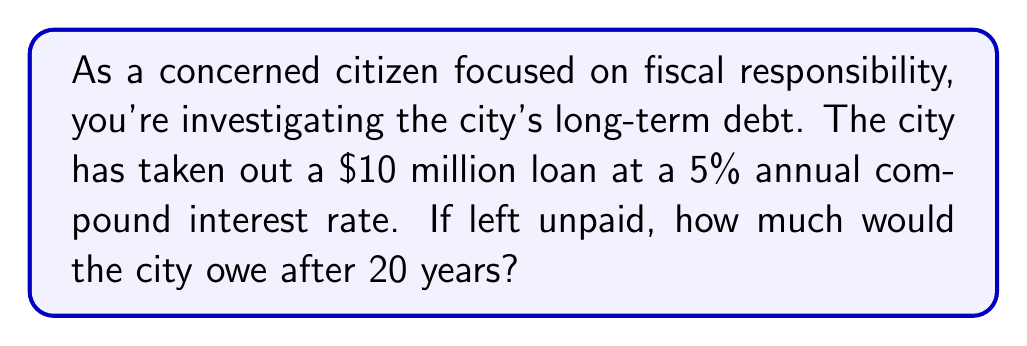Can you answer this question? To solve this problem, we'll use the compound interest formula:

$$ A = P(1 + r)^t $$

Where:
$A$ = Final amount
$P$ = Principal (initial amount)
$r$ = Annual interest rate (as a decimal)
$t$ = Time in years

Given:
$P = \$10,000,000$
$r = 0.05$ (5% converted to decimal)
$t = 20$ years

Let's substitute these values into the formula:

$$ A = 10,000,000(1 + 0.05)^{20} $$

Now, let's calculate step-by-step:

1) First, calculate $(1 + 0.05)^{20}$:
   $$(1.05)^{20} \approx 2.6532977$$

2) Multiply this by the principal:
   $$10,000,000 \times 2.6532977 = 26,532,977$$

Therefore, after 20 years, the city would owe $26,532,977.

This represents an increase of $16,532,977 over the original loan amount, highlighting the significant impact of compound interest over time and the importance of responsible debt management for the city's fiscal health.
Answer: $26,532,977 